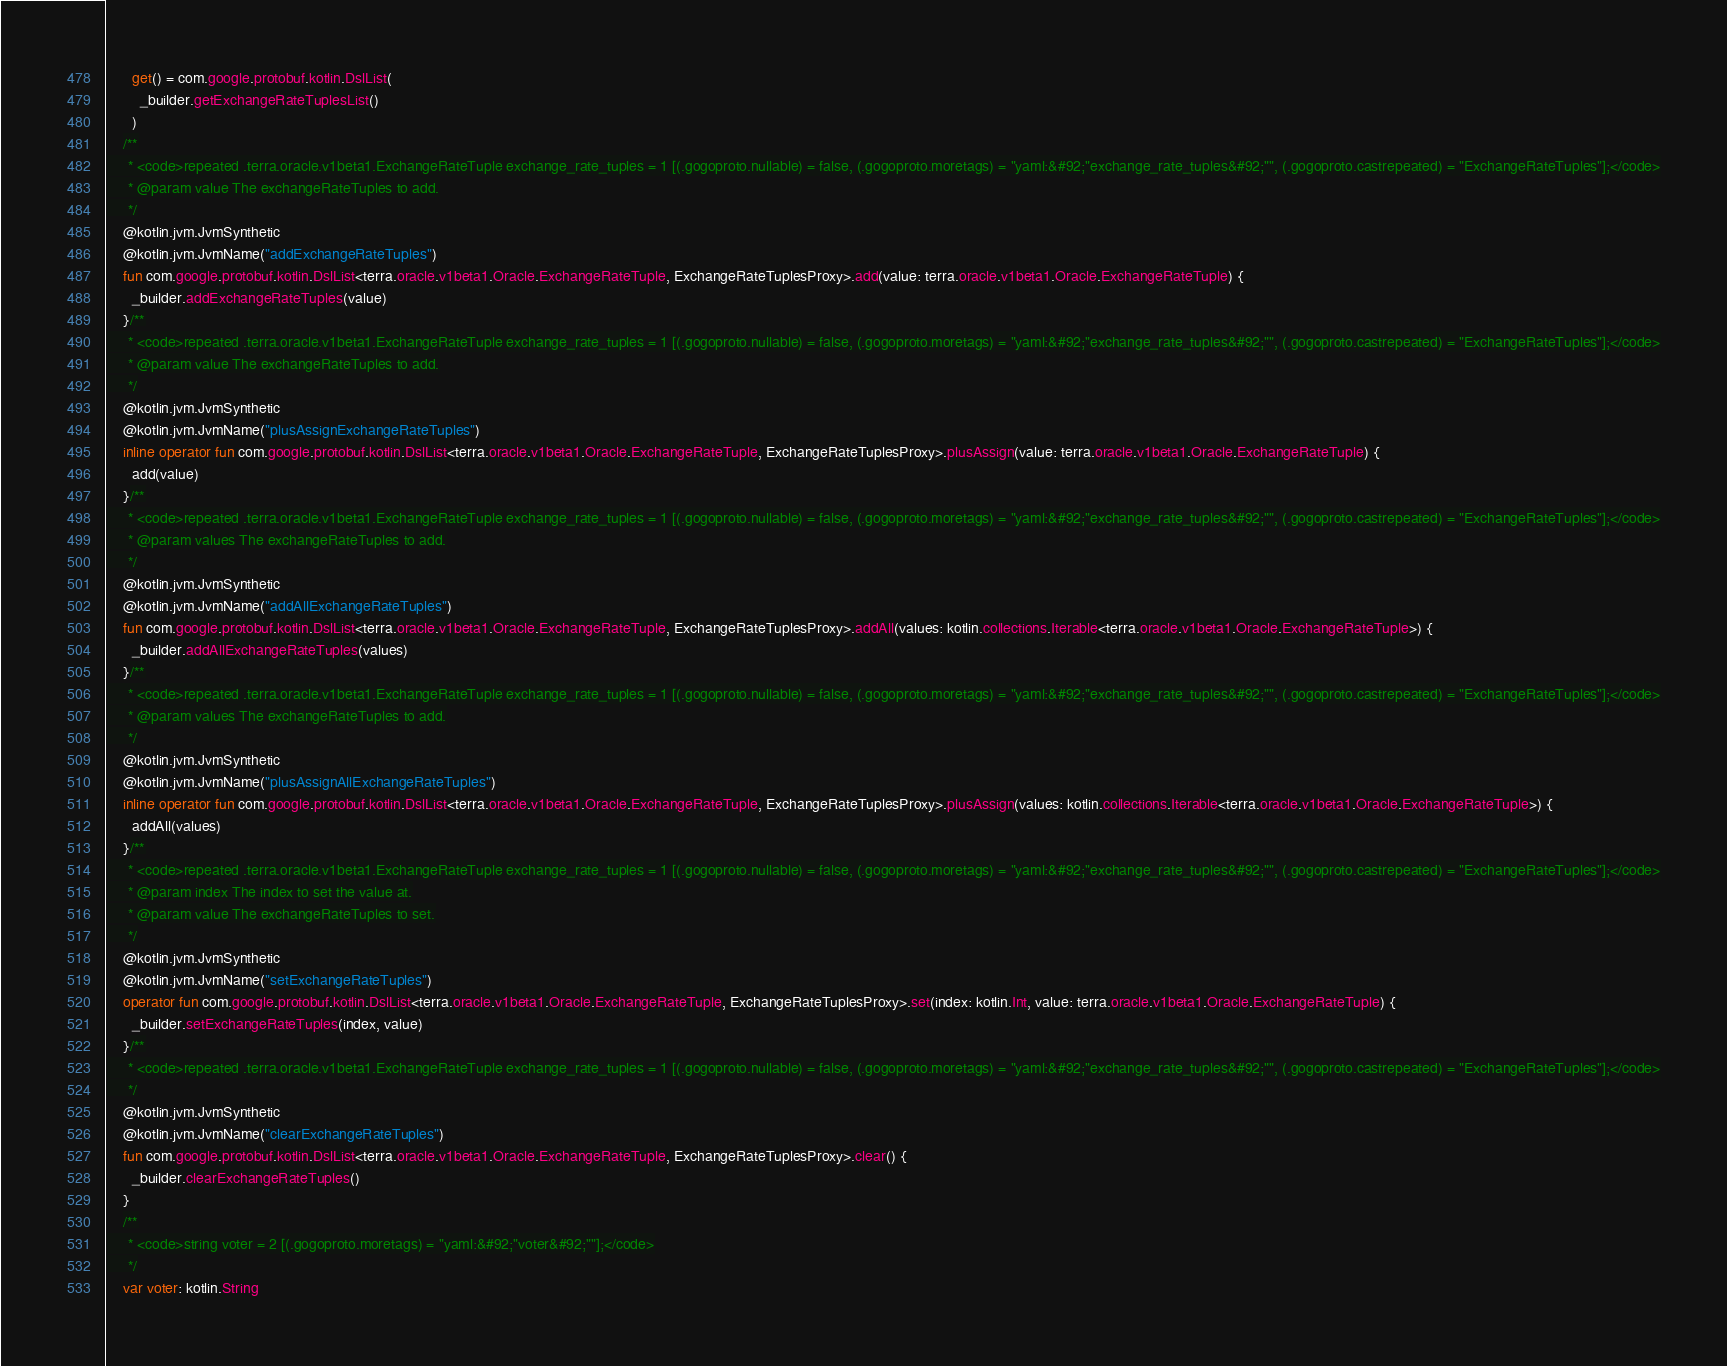Convert code to text. <code><loc_0><loc_0><loc_500><loc_500><_Kotlin_>      get() = com.google.protobuf.kotlin.DslList(
        _builder.getExchangeRateTuplesList()
      )
    /**
     * <code>repeated .terra.oracle.v1beta1.ExchangeRateTuple exchange_rate_tuples = 1 [(.gogoproto.nullable) = false, (.gogoproto.moretags) = "yaml:&#92;"exchange_rate_tuples&#92;"", (.gogoproto.castrepeated) = "ExchangeRateTuples"];</code>
     * @param value The exchangeRateTuples to add.
     */
    @kotlin.jvm.JvmSynthetic
    @kotlin.jvm.JvmName("addExchangeRateTuples")
    fun com.google.protobuf.kotlin.DslList<terra.oracle.v1beta1.Oracle.ExchangeRateTuple, ExchangeRateTuplesProxy>.add(value: terra.oracle.v1beta1.Oracle.ExchangeRateTuple) {
      _builder.addExchangeRateTuples(value)
    }/**
     * <code>repeated .terra.oracle.v1beta1.ExchangeRateTuple exchange_rate_tuples = 1 [(.gogoproto.nullable) = false, (.gogoproto.moretags) = "yaml:&#92;"exchange_rate_tuples&#92;"", (.gogoproto.castrepeated) = "ExchangeRateTuples"];</code>
     * @param value The exchangeRateTuples to add.
     */
    @kotlin.jvm.JvmSynthetic
    @kotlin.jvm.JvmName("plusAssignExchangeRateTuples")
    inline operator fun com.google.protobuf.kotlin.DslList<terra.oracle.v1beta1.Oracle.ExchangeRateTuple, ExchangeRateTuplesProxy>.plusAssign(value: terra.oracle.v1beta1.Oracle.ExchangeRateTuple) {
      add(value)
    }/**
     * <code>repeated .terra.oracle.v1beta1.ExchangeRateTuple exchange_rate_tuples = 1 [(.gogoproto.nullable) = false, (.gogoproto.moretags) = "yaml:&#92;"exchange_rate_tuples&#92;"", (.gogoproto.castrepeated) = "ExchangeRateTuples"];</code>
     * @param values The exchangeRateTuples to add.
     */
    @kotlin.jvm.JvmSynthetic
    @kotlin.jvm.JvmName("addAllExchangeRateTuples")
    fun com.google.protobuf.kotlin.DslList<terra.oracle.v1beta1.Oracle.ExchangeRateTuple, ExchangeRateTuplesProxy>.addAll(values: kotlin.collections.Iterable<terra.oracle.v1beta1.Oracle.ExchangeRateTuple>) {
      _builder.addAllExchangeRateTuples(values)
    }/**
     * <code>repeated .terra.oracle.v1beta1.ExchangeRateTuple exchange_rate_tuples = 1 [(.gogoproto.nullable) = false, (.gogoproto.moretags) = "yaml:&#92;"exchange_rate_tuples&#92;"", (.gogoproto.castrepeated) = "ExchangeRateTuples"];</code>
     * @param values The exchangeRateTuples to add.
     */
    @kotlin.jvm.JvmSynthetic
    @kotlin.jvm.JvmName("plusAssignAllExchangeRateTuples")
    inline operator fun com.google.protobuf.kotlin.DslList<terra.oracle.v1beta1.Oracle.ExchangeRateTuple, ExchangeRateTuplesProxy>.plusAssign(values: kotlin.collections.Iterable<terra.oracle.v1beta1.Oracle.ExchangeRateTuple>) {
      addAll(values)
    }/**
     * <code>repeated .terra.oracle.v1beta1.ExchangeRateTuple exchange_rate_tuples = 1 [(.gogoproto.nullable) = false, (.gogoproto.moretags) = "yaml:&#92;"exchange_rate_tuples&#92;"", (.gogoproto.castrepeated) = "ExchangeRateTuples"];</code>
     * @param index The index to set the value at.
     * @param value The exchangeRateTuples to set.
     */
    @kotlin.jvm.JvmSynthetic
    @kotlin.jvm.JvmName("setExchangeRateTuples")
    operator fun com.google.protobuf.kotlin.DslList<terra.oracle.v1beta1.Oracle.ExchangeRateTuple, ExchangeRateTuplesProxy>.set(index: kotlin.Int, value: terra.oracle.v1beta1.Oracle.ExchangeRateTuple) {
      _builder.setExchangeRateTuples(index, value)
    }/**
     * <code>repeated .terra.oracle.v1beta1.ExchangeRateTuple exchange_rate_tuples = 1 [(.gogoproto.nullable) = false, (.gogoproto.moretags) = "yaml:&#92;"exchange_rate_tuples&#92;"", (.gogoproto.castrepeated) = "ExchangeRateTuples"];</code>
     */
    @kotlin.jvm.JvmSynthetic
    @kotlin.jvm.JvmName("clearExchangeRateTuples")
    fun com.google.protobuf.kotlin.DslList<terra.oracle.v1beta1.Oracle.ExchangeRateTuple, ExchangeRateTuplesProxy>.clear() {
      _builder.clearExchangeRateTuples()
    }
    /**
     * <code>string voter = 2 [(.gogoproto.moretags) = "yaml:&#92;"voter&#92;""];</code>
     */
    var voter: kotlin.String</code> 